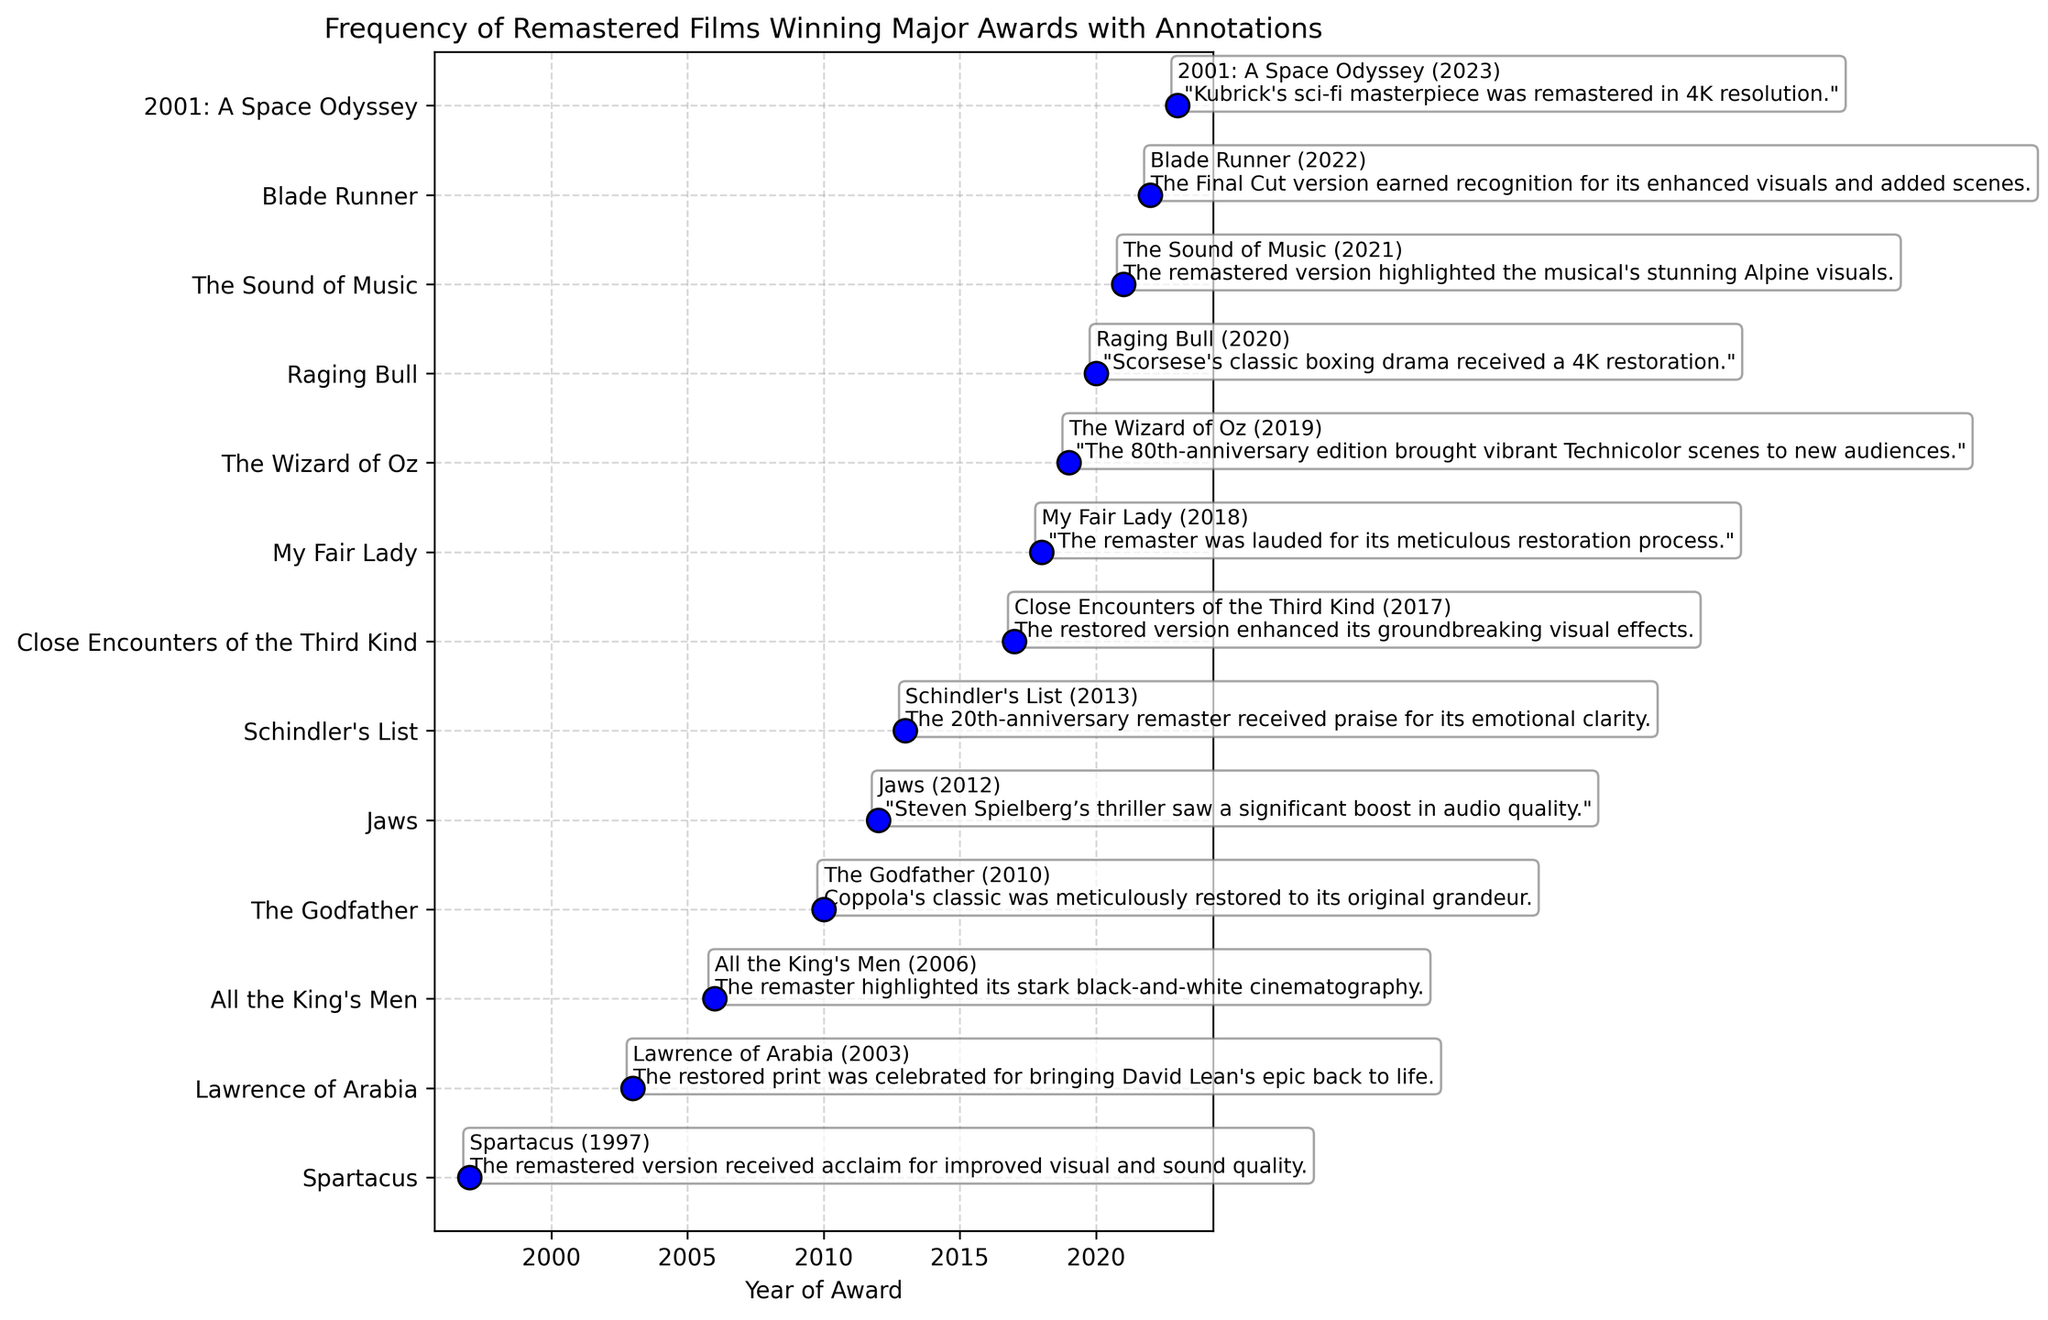Which film received an award in 2010? Find the year 2010 on the x-axis and locate which film corresponds to that point on the y-axis.
Answer: The Godfather What year did the film "Lawrence of Arabia" win its award after being remastered? Locate "Lawrence of Arabia" on the y-axis and check the year associated with it on the x-axis.
Answer: 2003 Which remastered film related to Stanley Kubrick won an award and in what year? Identify the film directed by Stanley Kubrick, "2001: A Space Odyssey", and find the year on the x-axis.
Answer: 2023 How many films won awards after being remastered in the same decade they were originally released? Count the number of films where the year of the remaster award falls within a decade of the original release year. This involves mathematical calculations comparing release and award years.
Answer: 2 (Blade Runner and Close Encounters of the Third Kind) Compare the annotations of "Jaws" and "Schindler's List". Which one mentions audio quality and which one mentions emotional clarity? Read the annotations for both films and identify the keywords related to audio quality for "Jaws" and emotional clarity for "Schindler's List".
Answer: Jaws - audio quality, Schindler's List - emotional clarity How many films won awards post-remaster between 2015 and 2020? Identify and count the number of award-winning remastered films within the x-axis range between 2015 and 2020.
Answer: 4 (The Sound of Music, My Fair Lady, The Wizard of Oz, Raging Bull) Which film had its 80th-anniversary edition win an award, and what was the award? Identify the film that mentions "80th-anniversary edition" in its annotation and check the associated award type.
Answer: The Wizard of Oz, Academy Award for Best Original Score Which award did the film "Spartacus" receive after being remastered? Locate "Spartacus" on the y-axis and refer to the specific award mentioned in its annotation.
Answer: Academy Award for Best Costume Design Which remastered film was celebrated for enhanced visual effects? Find the film whose annotation mentions "enhanced visual effects" and identify it.
Answer: Close Encounters of the Third Kind 